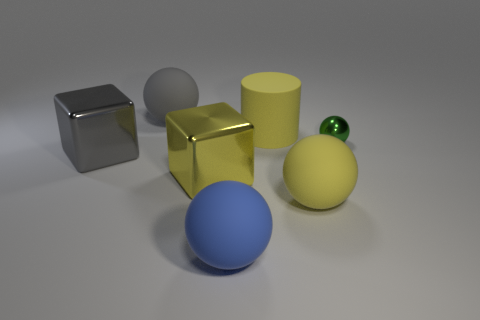Subtract 1 spheres. How many spheres are left? 3 Add 1 yellow rubber cylinders. How many objects exist? 8 Subtract all balls. How many objects are left? 3 Add 6 big yellow matte cylinders. How many big yellow matte cylinders are left? 7 Add 2 big cyan shiny cylinders. How many big cyan shiny cylinders exist? 2 Subtract 0 purple balls. How many objects are left? 7 Subtract all gray metal things. Subtract all shiny blocks. How many objects are left? 4 